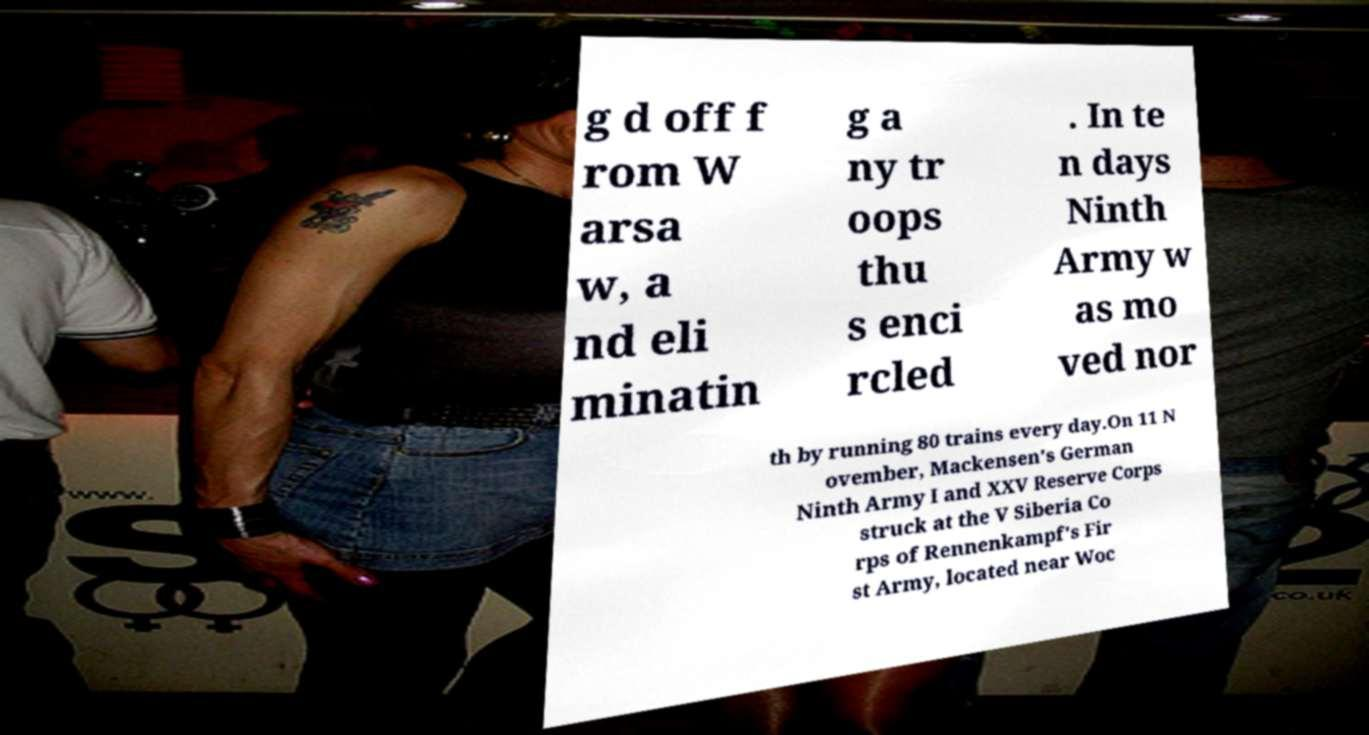Can you accurately transcribe the text from the provided image for me? g d off f rom W arsa w, a nd eli minatin g a ny tr oops thu s enci rcled . In te n days Ninth Army w as mo ved nor th by running 80 trains every day.On 11 N ovember, Mackensen's German Ninth Army I and XXV Reserve Corps struck at the V Siberia Co rps of Rennenkampf's Fir st Army, located near Woc 